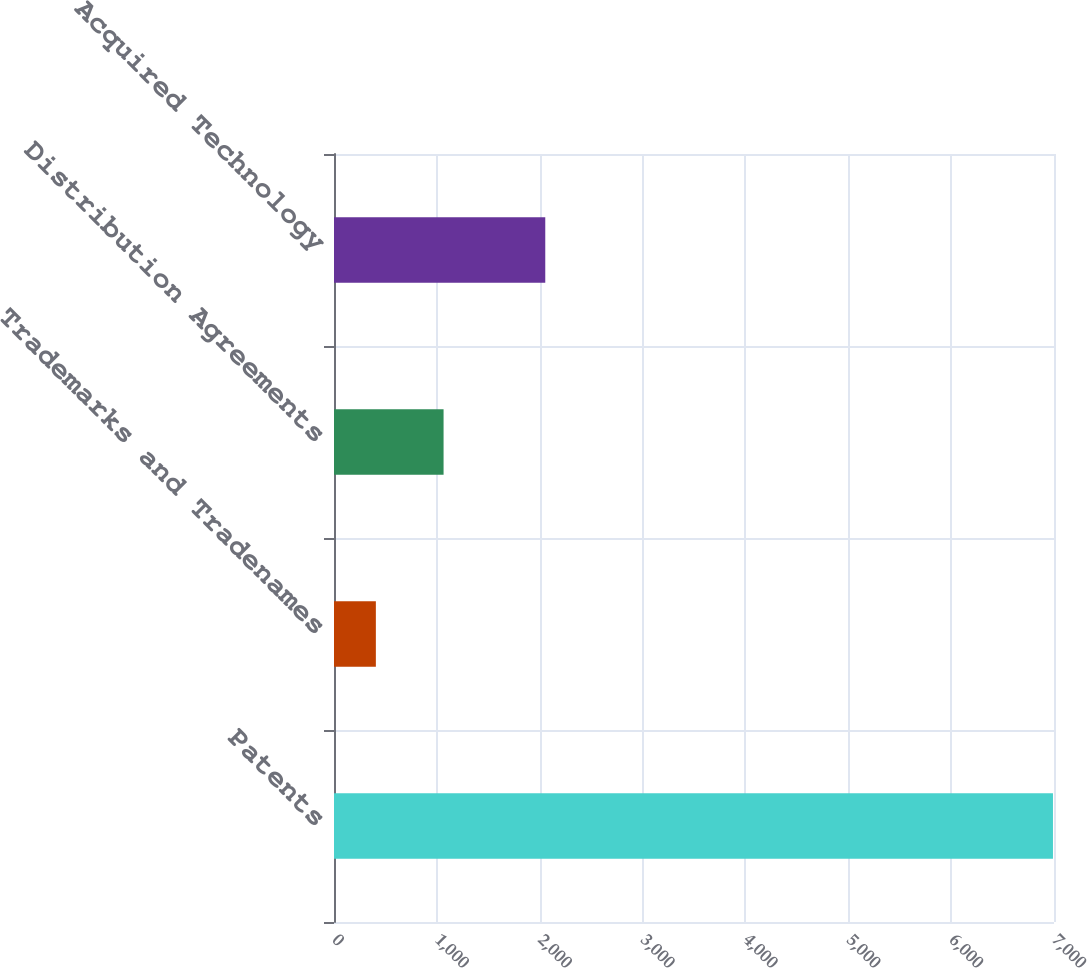Convert chart. <chart><loc_0><loc_0><loc_500><loc_500><bar_chart><fcel>Patents<fcel>Trademarks and Tradenames<fcel>Distribution Agreements<fcel>Acquired Technology<nl><fcel>6990<fcel>407<fcel>1065.3<fcel>2054<nl></chart> 